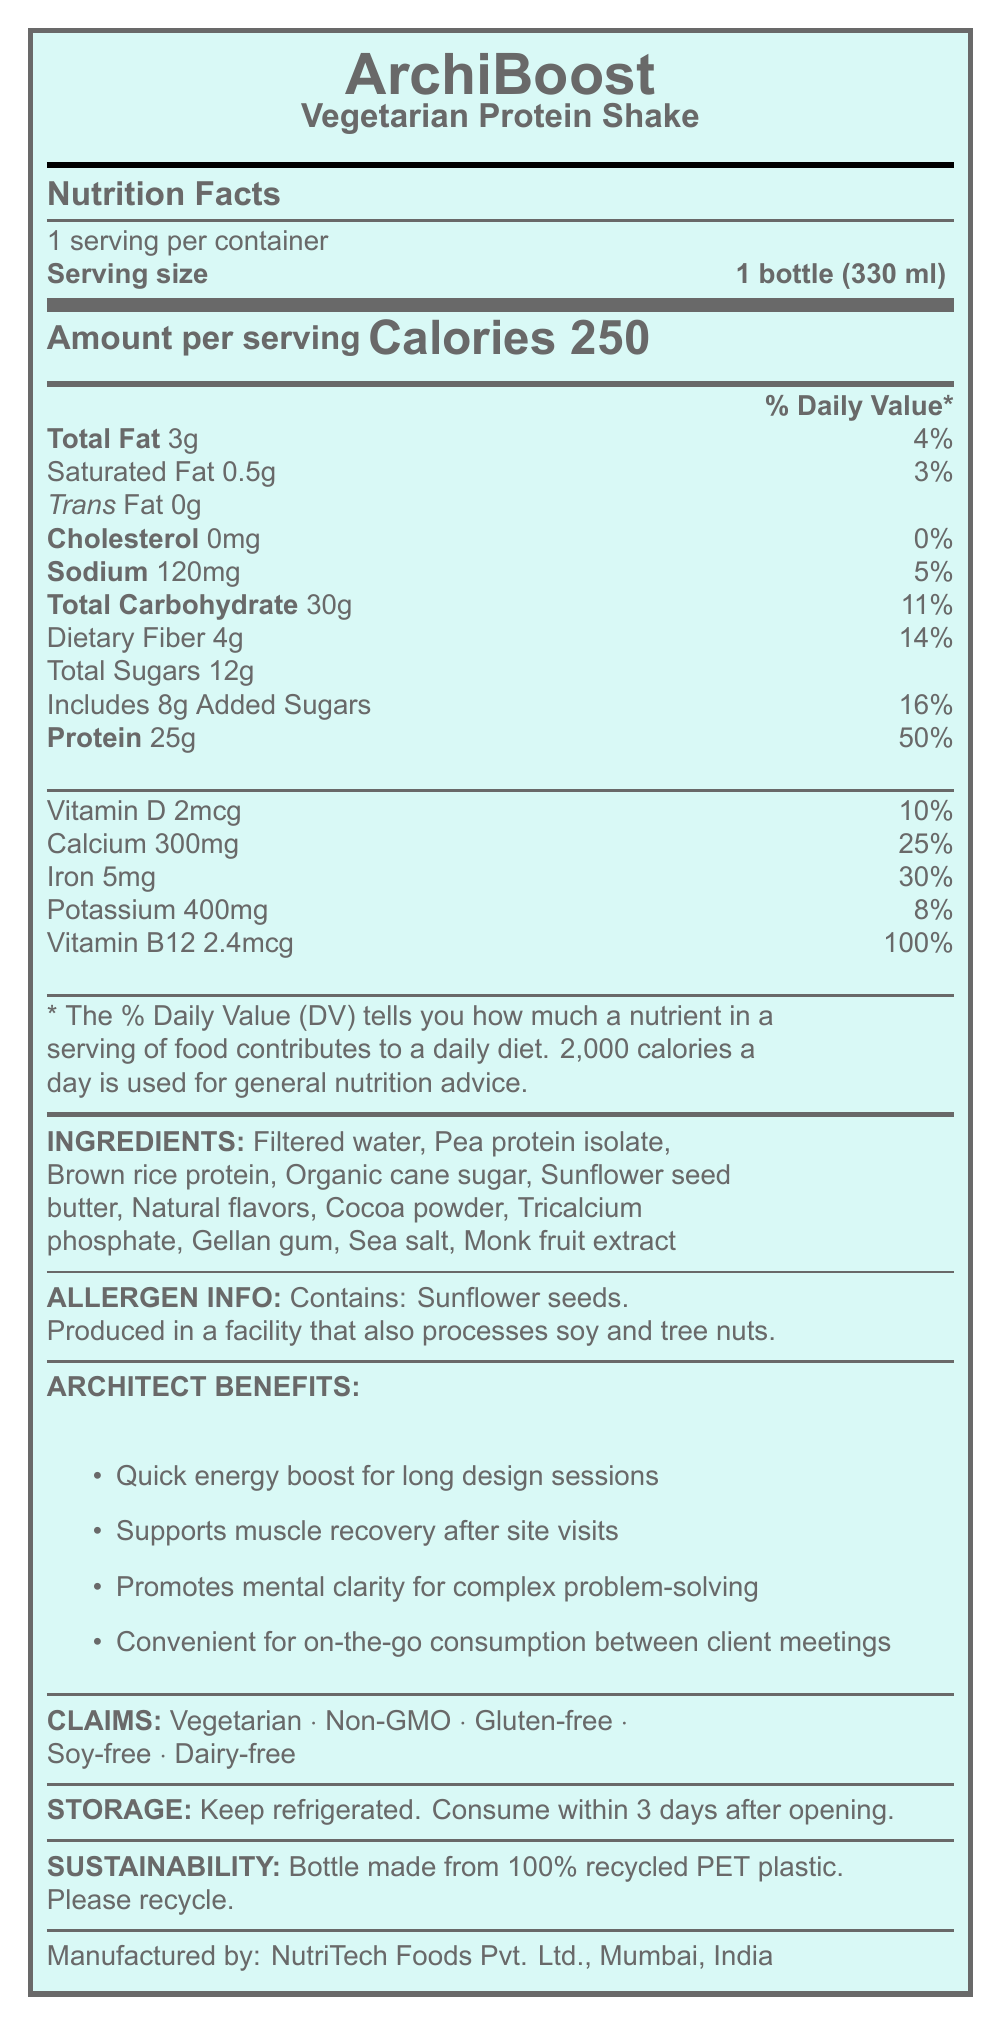what is the serving size of the ArchiBoost Vegetarian Protein Shake? The serving size is clearly stated under the "Serving size" section in the document.
Answer: 1 bottle (330 ml) how many calories are in one serving of the shake? The calorie count per serving is listed as 250 in the "Amount per serving" section.
Answer: 250 what is the amount of dietary fiber in the shake? The dietary fiber amount is mentioned as 4g under the "Dietary Fiber" section.
Answer: 4g how much protein does the shake provide? The amount of protein is clearly mentioned as 25g in the "Protein" section.
Answer: 25g what is the daily value percentage for vitamin B12 in the shake? The daily value percentage for vitamin B12 is listed as 100% under the "Vitamin B12" section.
Answer: 100% which of the following ingredients is present in the shake?
A. Soy protein isolate
B. Pea protein isolate
C. Whey protein isolate Pea protein isolate is listed in the ingredients section, while soy and whey protein isolates are not.
Answer: B how many grams of total sugars are in one serving? The total sugars amount is mentioned as 12g under the "Total Sugars" section.
Answer: 12g what allergens does the shake contain? The allergen information section states that the shake contains sunflower seeds.
Answer: Sunflower seeds which of the following statements about the shake are true?
A. It contains dairy
B. It is gluten-free
C. It contains cholesterol
D. It is non-GMO The shake is labeled as gluten-free and non-GMO, while it does not contain dairy or cholesterol.
Answer: B and D does the product support muscle recovery after site visits? The benefits section specifically mentions that the shake supports muscle recovery after site visits.
Answer: Yes describe the main idea of the document. The document is a comprehensive presentation of the ArchiBoost Vegetarian Protein Shake, including its nutrition facts, key ingredients, allergen information, benefits specifically for architects, and sustainability aspects.
Answer: The document provides detailed nutrition information for the ArchiBoost Vegetarian Protein Shake, highlighting its nutritional content, ingredients, allergen information, benefits for architects, and sustainability. what is the price of the ArchiBoost Vegetarian Protein Shake? The document does not provide any information about the price of the product.
Answer: Cannot be determined 